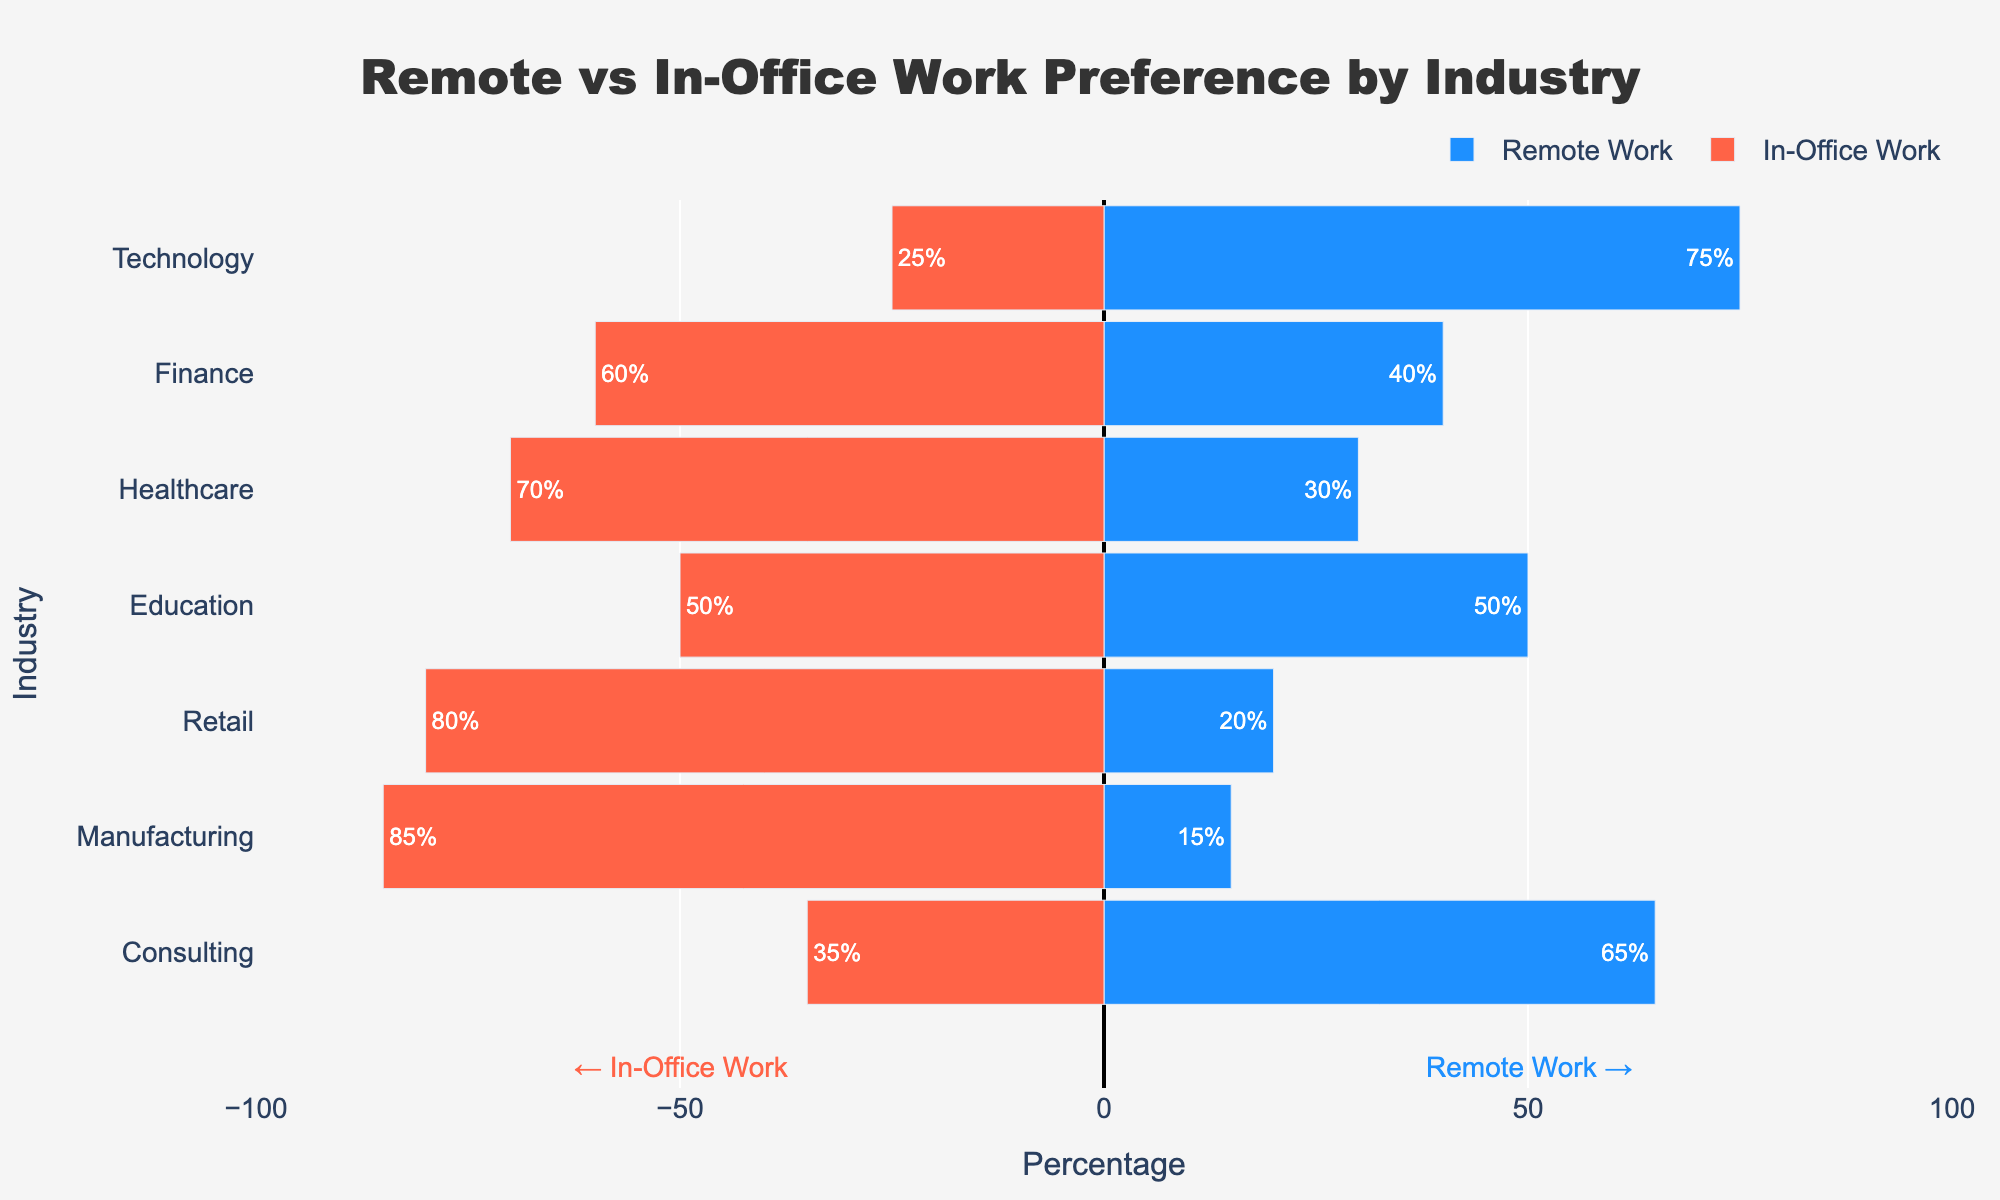Which industry has the highest preference for remote work? The highest preference for remote work is indicated by the longest blue bar (Remote Work) at 75% in the Technology industry.
Answer: Technology Which industry has the lowest preference for remote work? The lowest preference for remote work is indicated by the shortest blue bar (Remote Work) at 15% in the Manufacturing industry.
Answer: Manufacturing How does the preference for remote work in Consulting compare to Finance? Compare the length of the blue bars (Remote Work). Consulting has a 65% preference for remote work, while Finance has a 40% preference. Thus, Consulting has a higher preference.
Answer: Consulting has a higher preference What is the total percentage of in-office work preference for Healthcare and Retail combined? Look at the red bars (In-Office Work) for Healthcare and Retail. Healthcare has 70% and Retail has 80%. Sum these percentages: 70% + 80% = 150%.
Answer: 150% Which industry shows an equal preference for both remote work and in-office work? An equal preference is shown by the same lengths of blue (Remote Work) and red (In-Office Work) bars. Only Education shows 50% for both.
Answer: Education How does the preference for in-office work in Technology compare to that in Healthcare? Compare the lengths of the red bars (In-Office Work). Technology has 25% and Healthcare has 70%. Healthcare has a higher preference for in-office work.
Answer: Healthcare has a higher preference What is the difference in remote work preference between the Technology and Retail industries? Look at the blue bars (Remote Work) for Technology at 75% and Retail at 20%. Subtract Retail's percentage from Technology's: 75% - 20% = 55%.
Answer: 55% Which industry shows the highest overall preference (remote and in-office combined) for in-office work? The highest overall in-office preference is shown by the longest red bar (In-Office Work), which is 85% in Manufacturing.
Answer: Manufacturing What is the combined remote work preference percentage for Technology and Consulting? Combine the percentages from the blue bars (Remote Work) in Technology (75%) and Consulting (65%). Sum: 75% + 65% = 140%.
Answer: 140% In which industry is the difference between remote work and in-office work preferences the smallest? The smallest difference is where the blue and red bars are closest to each other. In Education, they are both 50%, so the difference is 0%.
Answer: Education 